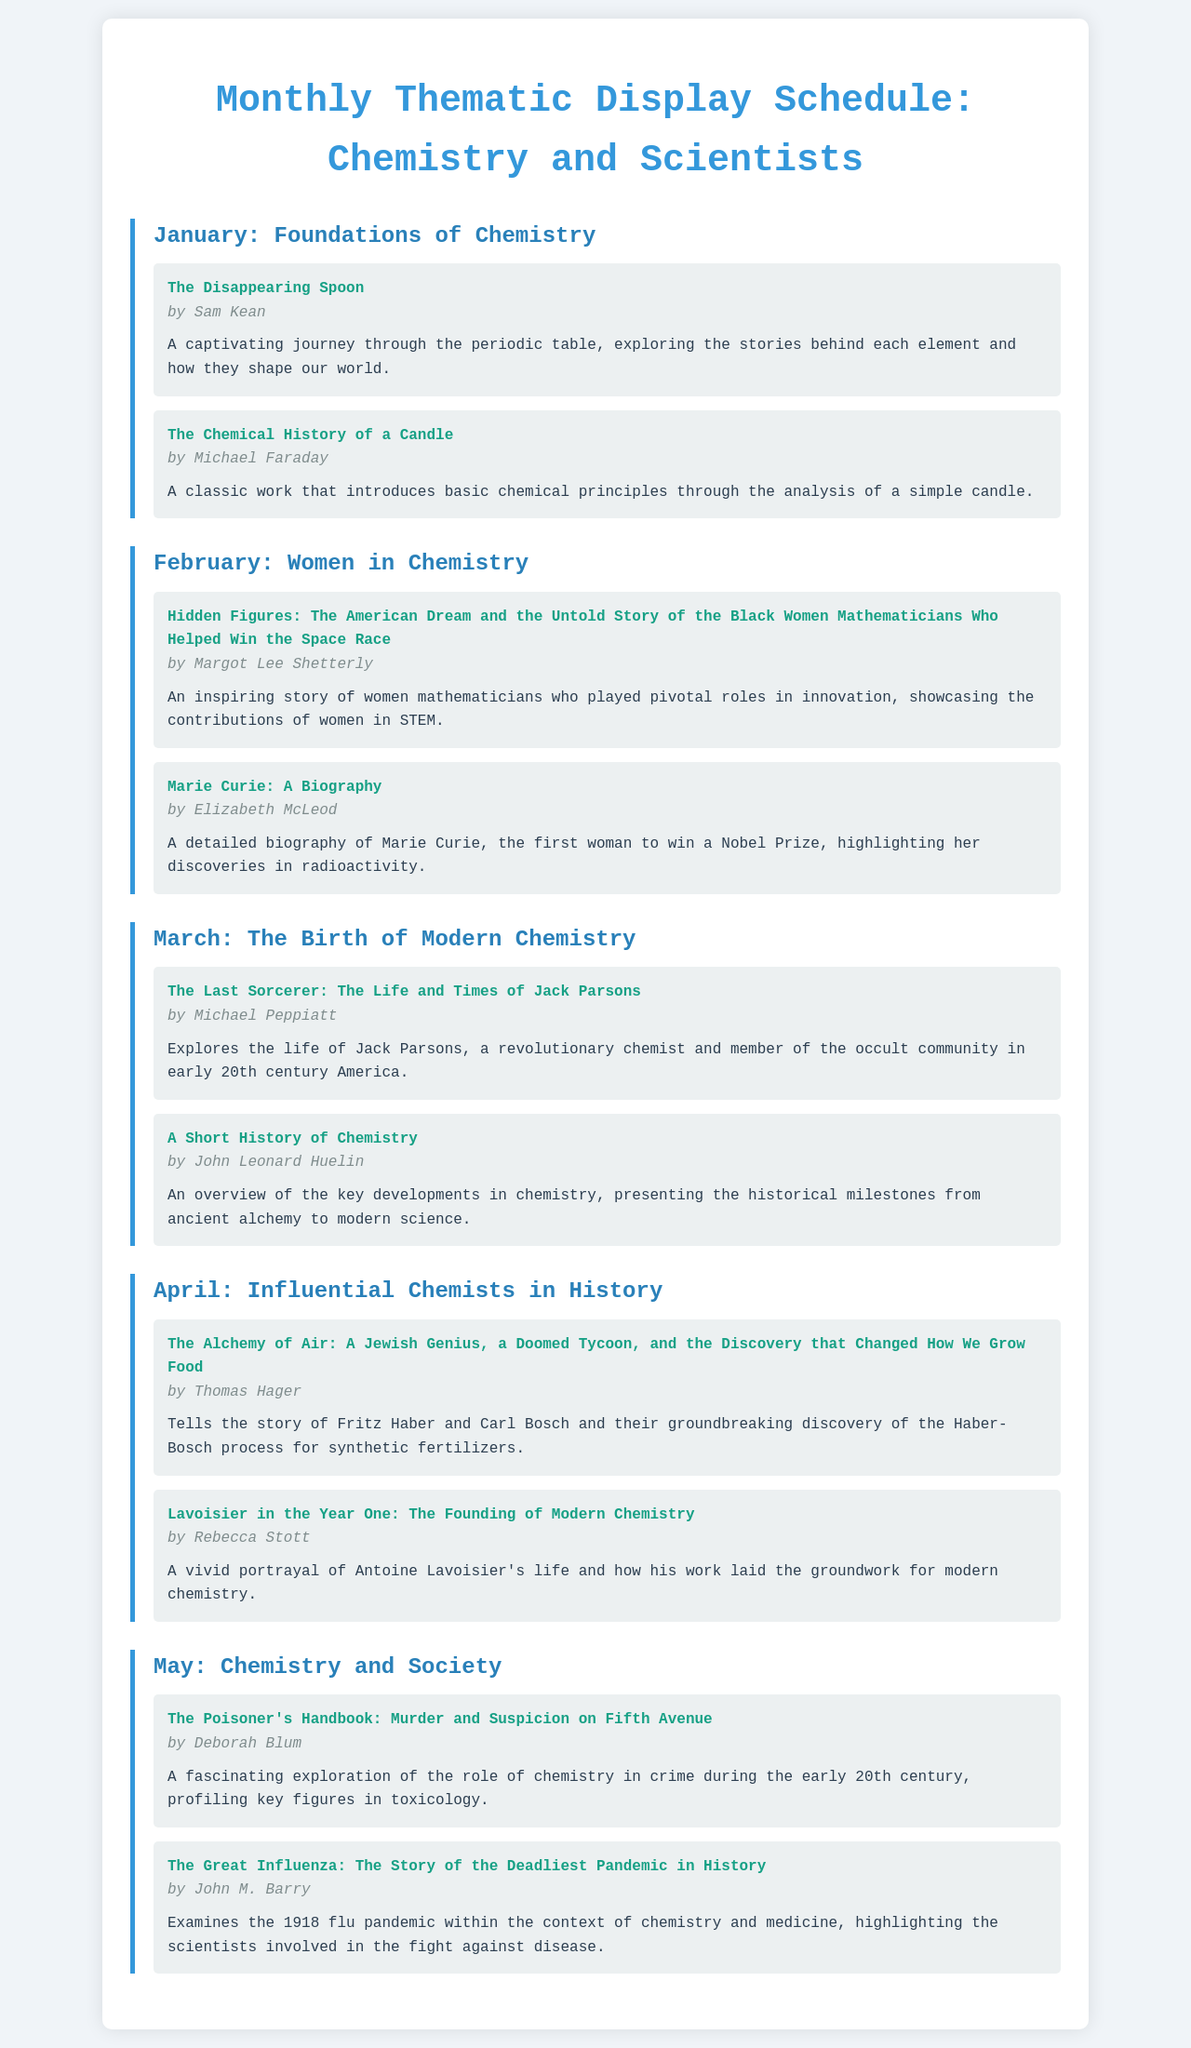What is the theme for January? January's theme focuses on the foundational aspects of chemistry as indicated in the title.
Answer: Foundations of Chemistry Who is the author of "The Disappearing Spoon"? The document states the author of this book, which is about the periodic table, is Sam Kean.
Answer: Sam Kean What book is featured in February about a famous woman in chemistry? The document specifies a biography of a celebrated woman chemist, which is highlighted for February's theme.
Answer: Marie Curie: A Biography Which two books are featured in April? Both titles and authors are mentioned in the document for the month of April, reflecting influential chemists.
Answer: The Alchemy of Air and Lavoisier in the Year One How many books are presented in the "Chemistry and Society" theme? The document shows the count of books featured under this specific monthly theme, allowing us to assess the volume.
Answer: 2 What is the author of "The Great Influenza"? The name of the author for this book included in the display schedule is found in the summary provided in the document.
Answer: John M. Barry What is the color of the headings in the document? The document visually describes the styling of the headings, specifying their color.
Answer: Blue Which month covers the contributions of women in science? The document lists the theme for February, directly correlating it with women in chemistry, answering the question.
Answer: February How many months are highlighted in the display schedule? The document gives a complete view of months covered, reflecting how many months feature thematic displays.
Answer: 5 